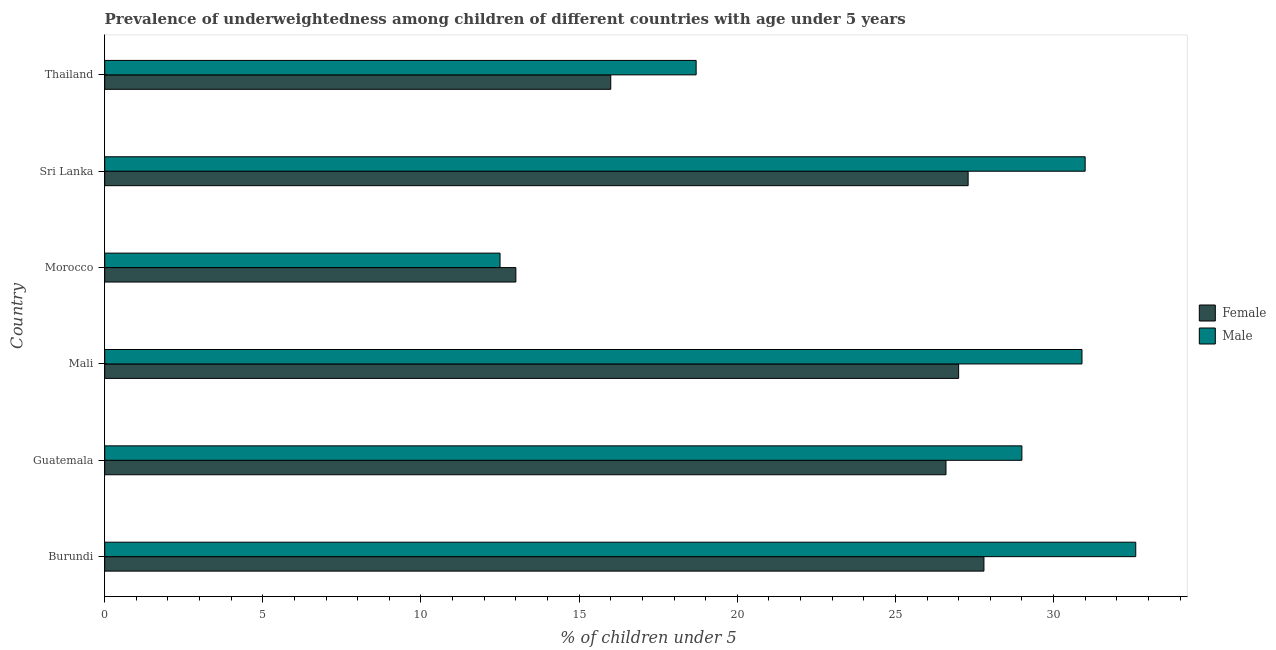How many different coloured bars are there?
Make the answer very short. 2. Are the number of bars per tick equal to the number of legend labels?
Ensure brevity in your answer.  Yes. How many bars are there on the 4th tick from the bottom?
Your response must be concise. 2. What is the label of the 5th group of bars from the top?
Give a very brief answer. Guatemala. In how many cases, is the number of bars for a given country not equal to the number of legend labels?
Your response must be concise. 0. What is the percentage of underweighted male children in Burundi?
Keep it short and to the point. 32.6. Across all countries, what is the maximum percentage of underweighted male children?
Ensure brevity in your answer.  32.6. In which country was the percentage of underweighted female children maximum?
Your response must be concise. Burundi. In which country was the percentage of underweighted female children minimum?
Your answer should be compact. Morocco. What is the total percentage of underweighted female children in the graph?
Make the answer very short. 137.7. What is the difference between the percentage of underweighted female children in Sri Lanka and that in Thailand?
Your answer should be very brief. 11.3. What is the difference between the percentage of underweighted male children in Thailand and the percentage of underweighted female children in Morocco?
Make the answer very short. 5.7. What is the average percentage of underweighted male children per country?
Your answer should be compact. 25.78. What is the ratio of the percentage of underweighted female children in Morocco to that in Thailand?
Give a very brief answer. 0.81. Is the percentage of underweighted male children in Morocco less than that in Thailand?
Your response must be concise. Yes. What is the difference between the highest and the second highest percentage of underweighted female children?
Provide a succinct answer. 0.5. What is the difference between the highest and the lowest percentage of underweighted male children?
Provide a short and direct response. 20.1. In how many countries, is the percentage of underweighted female children greater than the average percentage of underweighted female children taken over all countries?
Offer a terse response. 4. Is the sum of the percentage of underweighted female children in Burundi and Thailand greater than the maximum percentage of underweighted male children across all countries?
Offer a very short reply. Yes. How many countries are there in the graph?
Keep it short and to the point. 6. Does the graph contain any zero values?
Offer a very short reply. No. How many legend labels are there?
Your response must be concise. 2. What is the title of the graph?
Ensure brevity in your answer.  Prevalence of underweightedness among children of different countries with age under 5 years. What is the label or title of the X-axis?
Ensure brevity in your answer.   % of children under 5. What is the label or title of the Y-axis?
Give a very brief answer. Country. What is the  % of children under 5 of Female in Burundi?
Ensure brevity in your answer.  27.8. What is the  % of children under 5 of Male in Burundi?
Give a very brief answer. 32.6. What is the  % of children under 5 of Female in Guatemala?
Provide a short and direct response. 26.6. What is the  % of children under 5 in Male in Mali?
Give a very brief answer. 30.9. What is the  % of children under 5 in Female in Sri Lanka?
Make the answer very short. 27.3. What is the  % of children under 5 in Male in Sri Lanka?
Offer a terse response. 31. What is the  % of children under 5 of Male in Thailand?
Keep it short and to the point. 18.7. Across all countries, what is the maximum  % of children under 5 in Female?
Your response must be concise. 27.8. Across all countries, what is the maximum  % of children under 5 in Male?
Offer a terse response. 32.6. Across all countries, what is the minimum  % of children under 5 of Female?
Ensure brevity in your answer.  13. What is the total  % of children under 5 in Female in the graph?
Your answer should be compact. 137.7. What is the total  % of children under 5 in Male in the graph?
Make the answer very short. 154.7. What is the difference between the  % of children under 5 of Female in Burundi and that in Guatemala?
Your response must be concise. 1.2. What is the difference between the  % of children under 5 in Male in Burundi and that in Morocco?
Provide a succinct answer. 20.1. What is the difference between the  % of children under 5 in Female in Burundi and that in Sri Lanka?
Your answer should be very brief. 0.5. What is the difference between the  % of children under 5 in Female in Guatemala and that in Mali?
Give a very brief answer. -0.4. What is the difference between the  % of children under 5 in Female in Guatemala and that in Morocco?
Ensure brevity in your answer.  13.6. What is the difference between the  % of children under 5 in Male in Guatemala and that in Morocco?
Your answer should be compact. 16.5. What is the difference between the  % of children under 5 in Female in Guatemala and that in Sri Lanka?
Offer a very short reply. -0.7. What is the difference between the  % of children under 5 in Female in Mali and that in Morocco?
Offer a terse response. 14. What is the difference between the  % of children under 5 of Female in Mali and that in Sri Lanka?
Offer a terse response. -0.3. What is the difference between the  % of children under 5 in Male in Mali and that in Sri Lanka?
Your response must be concise. -0.1. What is the difference between the  % of children under 5 of Male in Mali and that in Thailand?
Your response must be concise. 12.2. What is the difference between the  % of children under 5 of Female in Morocco and that in Sri Lanka?
Provide a succinct answer. -14.3. What is the difference between the  % of children under 5 of Male in Morocco and that in Sri Lanka?
Offer a terse response. -18.5. What is the difference between the  % of children under 5 of Female in Morocco and that in Thailand?
Your response must be concise. -3. What is the difference between the  % of children under 5 in Male in Morocco and that in Thailand?
Your answer should be compact. -6.2. What is the difference between the  % of children under 5 in Female in Sri Lanka and that in Thailand?
Make the answer very short. 11.3. What is the difference between the  % of children under 5 of Male in Sri Lanka and that in Thailand?
Provide a short and direct response. 12.3. What is the difference between the  % of children under 5 of Female in Burundi and the  % of children under 5 of Male in Guatemala?
Provide a short and direct response. -1.2. What is the difference between the  % of children under 5 of Female in Burundi and the  % of children under 5 of Male in Morocco?
Your answer should be compact. 15.3. What is the difference between the  % of children under 5 of Female in Burundi and the  % of children under 5 of Male in Sri Lanka?
Your answer should be very brief. -3.2. What is the difference between the  % of children under 5 in Female in Guatemala and the  % of children under 5 in Male in Mali?
Offer a terse response. -4.3. What is the difference between the  % of children under 5 in Female in Guatemala and the  % of children under 5 in Male in Morocco?
Keep it short and to the point. 14.1. What is the difference between the  % of children under 5 of Female in Guatemala and the  % of children under 5 of Male in Thailand?
Make the answer very short. 7.9. What is the difference between the  % of children under 5 in Female in Mali and the  % of children under 5 in Male in Morocco?
Your response must be concise. 14.5. What is the difference between the  % of children under 5 in Female in Mali and the  % of children under 5 in Male in Sri Lanka?
Provide a succinct answer. -4. What is the difference between the  % of children under 5 in Female in Mali and the  % of children under 5 in Male in Thailand?
Give a very brief answer. 8.3. What is the difference between the  % of children under 5 of Female in Morocco and the  % of children under 5 of Male in Sri Lanka?
Your answer should be compact. -18. What is the difference between the  % of children under 5 of Female in Morocco and the  % of children under 5 of Male in Thailand?
Offer a very short reply. -5.7. What is the difference between the  % of children under 5 of Female in Sri Lanka and the  % of children under 5 of Male in Thailand?
Your answer should be compact. 8.6. What is the average  % of children under 5 of Female per country?
Your answer should be very brief. 22.95. What is the average  % of children under 5 of Male per country?
Keep it short and to the point. 25.78. What is the difference between the  % of children under 5 of Female and  % of children under 5 of Male in Guatemala?
Your answer should be compact. -2.4. What is the difference between the  % of children under 5 in Female and  % of children under 5 in Male in Morocco?
Your answer should be compact. 0.5. What is the difference between the  % of children under 5 of Female and  % of children under 5 of Male in Thailand?
Offer a terse response. -2.7. What is the ratio of the  % of children under 5 in Female in Burundi to that in Guatemala?
Offer a very short reply. 1.05. What is the ratio of the  % of children under 5 in Male in Burundi to that in Guatemala?
Provide a short and direct response. 1.12. What is the ratio of the  % of children under 5 in Female in Burundi to that in Mali?
Keep it short and to the point. 1.03. What is the ratio of the  % of children under 5 of Male in Burundi to that in Mali?
Give a very brief answer. 1.05. What is the ratio of the  % of children under 5 in Female in Burundi to that in Morocco?
Keep it short and to the point. 2.14. What is the ratio of the  % of children under 5 in Male in Burundi to that in Morocco?
Provide a succinct answer. 2.61. What is the ratio of the  % of children under 5 of Female in Burundi to that in Sri Lanka?
Provide a short and direct response. 1.02. What is the ratio of the  % of children under 5 of Male in Burundi to that in Sri Lanka?
Your answer should be compact. 1.05. What is the ratio of the  % of children under 5 of Female in Burundi to that in Thailand?
Offer a terse response. 1.74. What is the ratio of the  % of children under 5 of Male in Burundi to that in Thailand?
Your answer should be very brief. 1.74. What is the ratio of the  % of children under 5 of Female in Guatemala to that in Mali?
Give a very brief answer. 0.99. What is the ratio of the  % of children under 5 of Male in Guatemala to that in Mali?
Give a very brief answer. 0.94. What is the ratio of the  % of children under 5 in Female in Guatemala to that in Morocco?
Make the answer very short. 2.05. What is the ratio of the  % of children under 5 in Male in Guatemala to that in Morocco?
Your answer should be very brief. 2.32. What is the ratio of the  % of children under 5 in Female in Guatemala to that in Sri Lanka?
Your response must be concise. 0.97. What is the ratio of the  % of children under 5 in Male in Guatemala to that in Sri Lanka?
Give a very brief answer. 0.94. What is the ratio of the  % of children under 5 in Female in Guatemala to that in Thailand?
Provide a short and direct response. 1.66. What is the ratio of the  % of children under 5 of Male in Guatemala to that in Thailand?
Make the answer very short. 1.55. What is the ratio of the  % of children under 5 in Female in Mali to that in Morocco?
Provide a succinct answer. 2.08. What is the ratio of the  % of children under 5 of Male in Mali to that in Morocco?
Make the answer very short. 2.47. What is the ratio of the  % of children under 5 of Female in Mali to that in Sri Lanka?
Give a very brief answer. 0.99. What is the ratio of the  % of children under 5 in Female in Mali to that in Thailand?
Give a very brief answer. 1.69. What is the ratio of the  % of children under 5 in Male in Mali to that in Thailand?
Your answer should be very brief. 1.65. What is the ratio of the  % of children under 5 of Female in Morocco to that in Sri Lanka?
Your response must be concise. 0.48. What is the ratio of the  % of children under 5 in Male in Morocco to that in Sri Lanka?
Give a very brief answer. 0.4. What is the ratio of the  % of children under 5 of Female in Morocco to that in Thailand?
Keep it short and to the point. 0.81. What is the ratio of the  % of children under 5 in Male in Morocco to that in Thailand?
Provide a short and direct response. 0.67. What is the ratio of the  % of children under 5 of Female in Sri Lanka to that in Thailand?
Keep it short and to the point. 1.71. What is the ratio of the  % of children under 5 of Male in Sri Lanka to that in Thailand?
Provide a short and direct response. 1.66. What is the difference between the highest and the second highest  % of children under 5 of Female?
Offer a terse response. 0.5. What is the difference between the highest and the second highest  % of children under 5 in Male?
Provide a succinct answer. 1.6. What is the difference between the highest and the lowest  % of children under 5 of Female?
Ensure brevity in your answer.  14.8. What is the difference between the highest and the lowest  % of children under 5 in Male?
Your answer should be very brief. 20.1. 